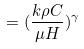Convert formula to latex. <formula><loc_0><loc_0><loc_500><loc_500>= ( \frac { k \rho C } { \mu H } ) ^ { \gamma }</formula> 